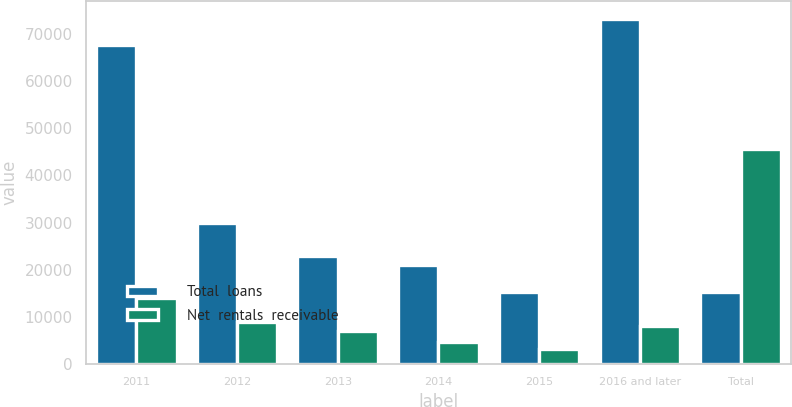<chart> <loc_0><loc_0><loc_500><loc_500><stacked_bar_chart><ecel><fcel>2011<fcel>2012<fcel>2013<fcel>2014<fcel>2015<fcel>2016 and later<fcel>Total<nl><fcel>Total  loans<fcel>67741<fcel>29947<fcel>22877<fcel>21074<fcel>15280<fcel>73296<fcel>15280<nl><fcel>Net  rentals  receivable<fcel>13978<fcel>8921<fcel>6961<fcel>4610<fcel>3043<fcel>8054<fcel>45567<nl></chart> 